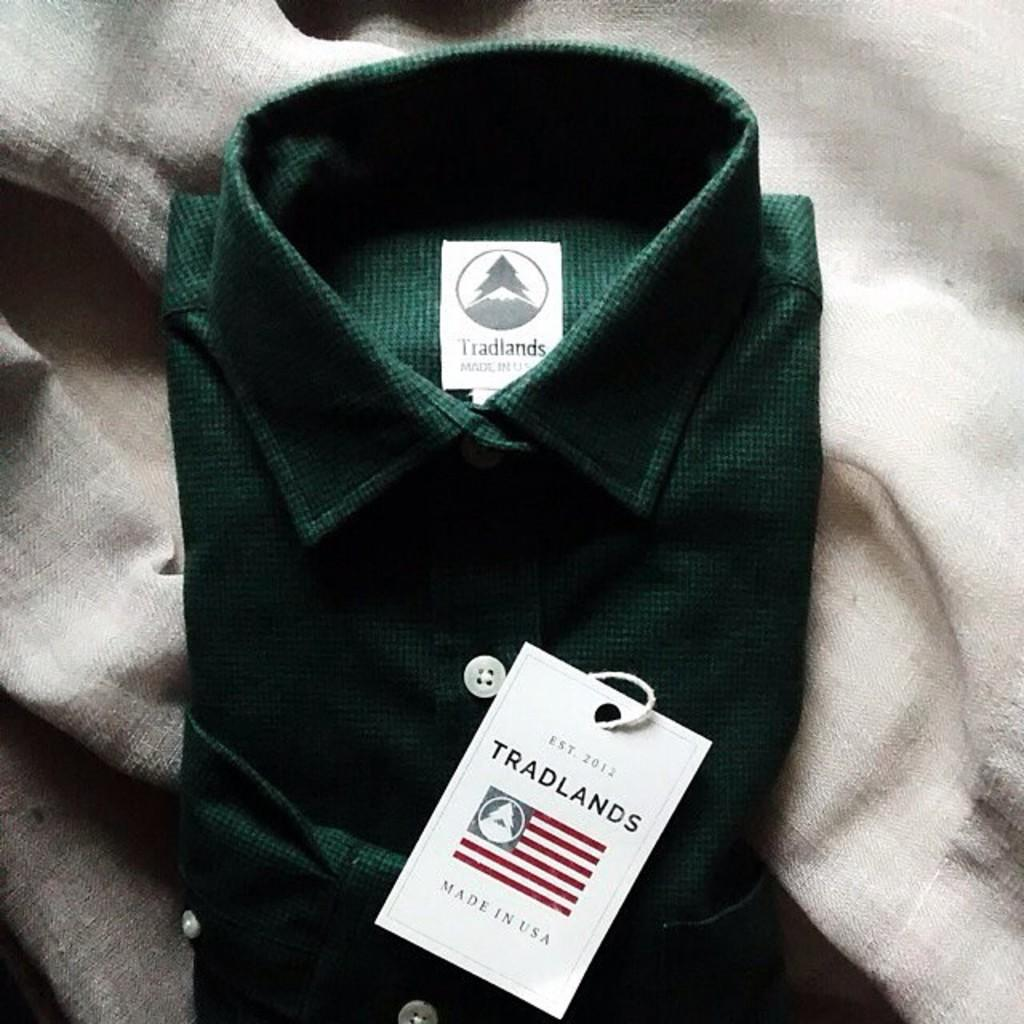What color is the shirt in the image? The shirt in the image is green. Is there any additional information about the shirt's appearance? Yes, there is a white color tag on the shirt. What type of watch is the person wearing in the image? There is no person or watch visible in the image; it only features a green shirt with a white color tag. 